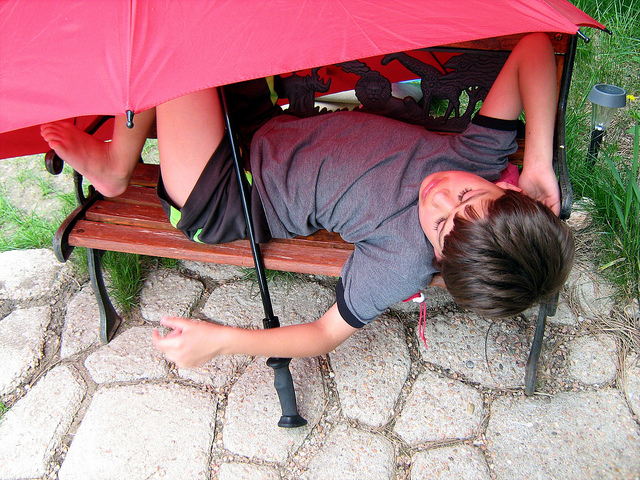<image>What is this person showing? I am not sure what the person is showing. It could be their face, legs, or an umbrella. What is this person showing? I don't know what this person is showing. It could be their face, legs, or umbrella. 